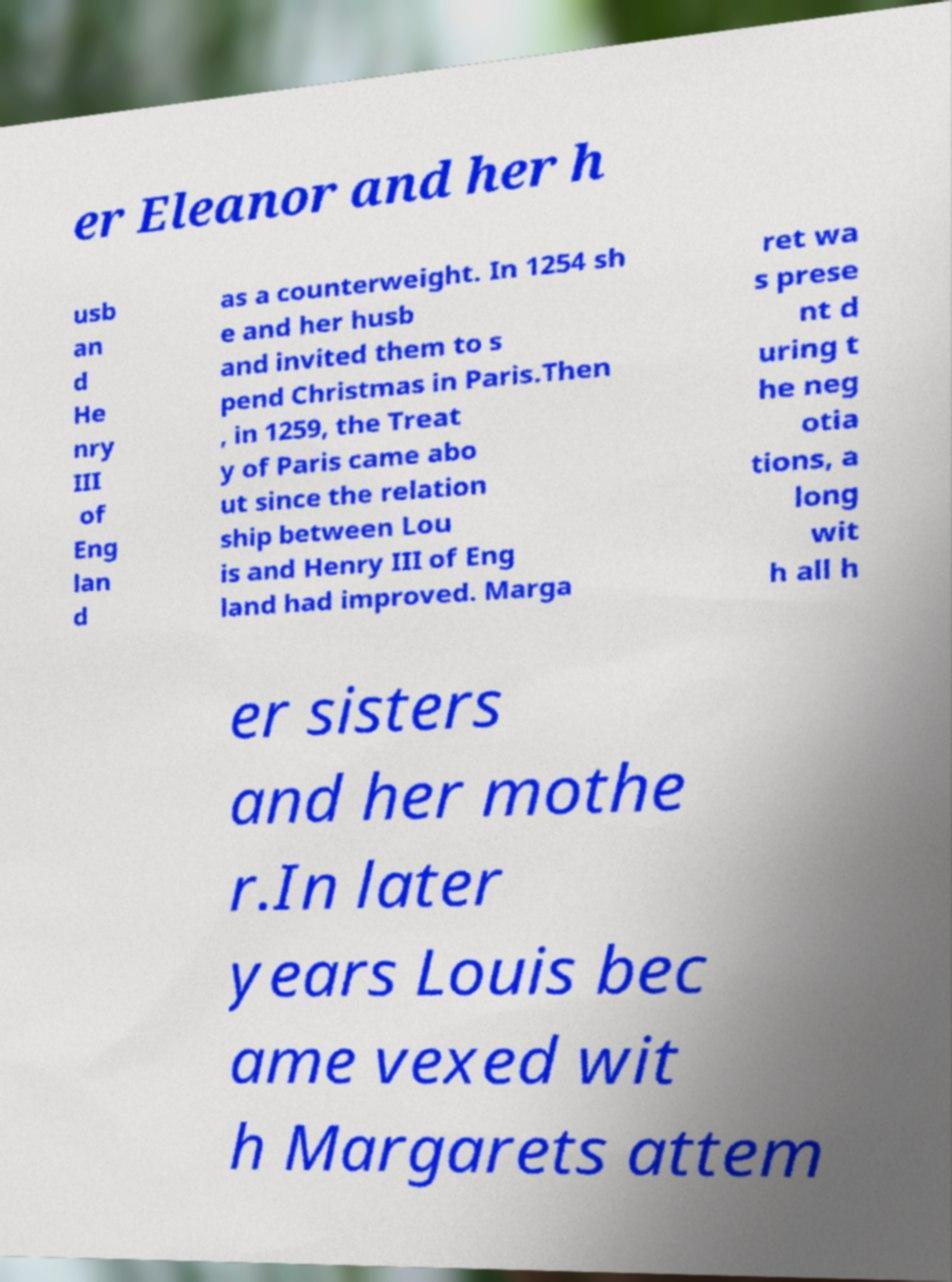For documentation purposes, I need the text within this image transcribed. Could you provide that? er Eleanor and her h usb an d He nry III of Eng lan d as a counterweight. In 1254 sh e and her husb and invited them to s pend Christmas in Paris.Then , in 1259, the Treat y of Paris came abo ut since the relation ship between Lou is and Henry III of Eng land had improved. Marga ret wa s prese nt d uring t he neg otia tions, a long wit h all h er sisters and her mothe r.In later years Louis bec ame vexed wit h Margarets attem 